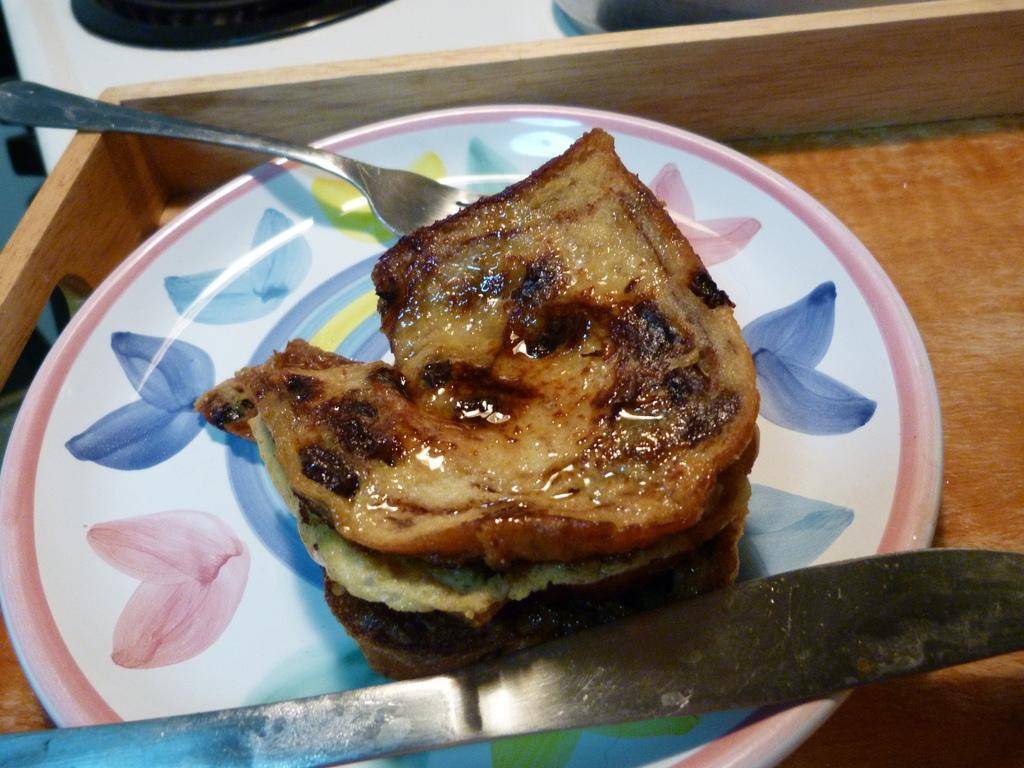What is the main object in the image? There is a wooden tray in the image. What is on the wooden tray? The tray has a plate on it. What is on the plate? The plate contains food. What utensils are on the plate? There is a fork and a knife on the plate. Can you describe the unspecified object in the left top corner of the image? Unfortunately, the facts provided do not give any information about the object in the left top corner of the image. What type of hospital is depicted in the image? There is no hospital depicted in the image. The image features a wooden tray with a plate containing food, along with a fork and a knife. 